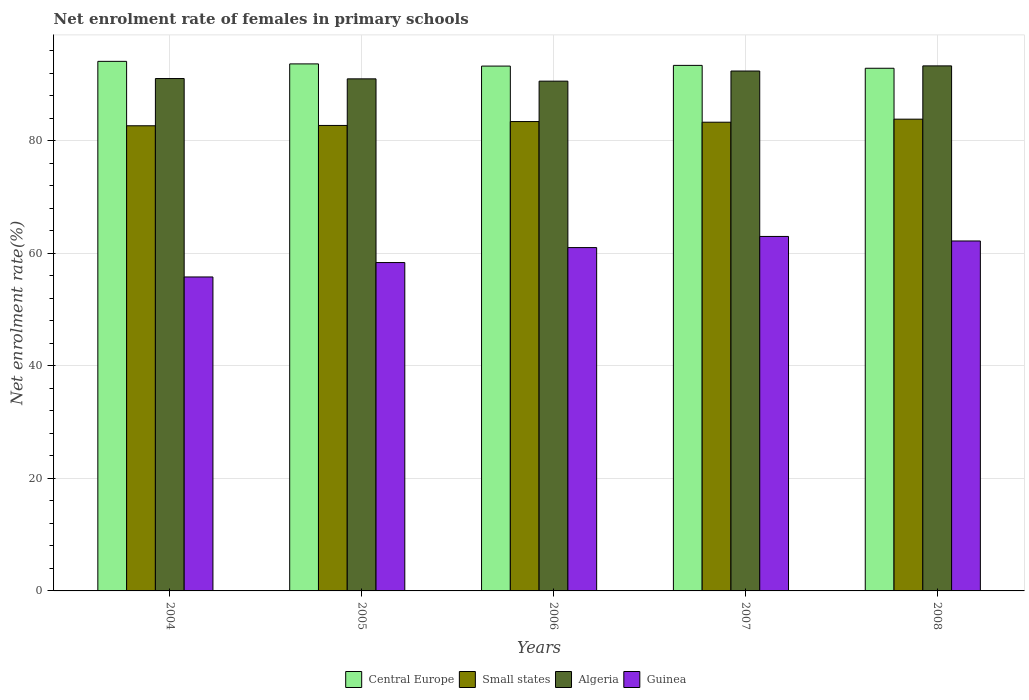How many groups of bars are there?
Your answer should be compact. 5. Are the number of bars per tick equal to the number of legend labels?
Offer a terse response. Yes. Are the number of bars on each tick of the X-axis equal?
Give a very brief answer. Yes. How many bars are there on the 4th tick from the left?
Give a very brief answer. 4. How many bars are there on the 3rd tick from the right?
Your response must be concise. 4. What is the label of the 4th group of bars from the left?
Your answer should be compact. 2007. What is the net enrolment rate of females in primary schools in Small states in 2005?
Make the answer very short. 82.73. Across all years, what is the maximum net enrolment rate of females in primary schools in Central Europe?
Make the answer very short. 94.12. Across all years, what is the minimum net enrolment rate of females in primary schools in Central Europe?
Your answer should be compact. 92.89. In which year was the net enrolment rate of females in primary schools in Algeria maximum?
Offer a very short reply. 2008. What is the total net enrolment rate of females in primary schools in Guinea in the graph?
Ensure brevity in your answer.  300.38. What is the difference between the net enrolment rate of females in primary schools in Central Europe in 2005 and that in 2006?
Your answer should be very brief. 0.39. What is the difference between the net enrolment rate of females in primary schools in Central Europe in 2008 and the net enrolment rate of females in primary schools in Small states in 2006?
Your answer should be compact. 9.47. What is the average net enrolment rate of females in primary schools in Algeria per year?
Your response must be concise. 91.68. In the year 2004, what is the difference between the net enrolment rate of females in primary schools in Algeria and net enrolment rate of females in primary schools in Guinea?
Offer a very short reply. 35.26. In how many years, is the net enrolment rate of females in primary schools in Algeria greater than 44 %?
Your answer should be very brief. 5. What is the ratio of the net enrolment rate of females in primary schools in Central Europe in 2004 to that in 2006?
Offer a terse response. 1.01. What is the difference between the highest and the second highest net enrolment rate of females in primary schools in Algeria?
Keep it short and to the point. 0.91. What is the difference between the highest and the lowest net enrolment rate of females in primary schools in Algeria?
Offer a terse response. 2.71. In how many years, is the net enrolment rate of females in primary schools in Guinea greater than the average net enrolment rate of females in primary schools in Guinea taken over all years?
Offer a terse response. 3. Is the sum of the net enrolment rate of females in primary schools in Central Europe in 2004 and 2006 greater than the maximum net enrolment rate of females in primary schools in Guinea across all years?
Make the answer very short. Yes. Is it the case that in every year, the sum of the net enrolment rate of females in primary schools in Guinea and net enrolment rate of females in primary schools in Central Europe is greater than the sum of net enrolment rate of females in primary schools in Algeria and net enrolment rate of females in primary schools in Small states?
Offer a very short reply. Yes. What does the 2nd bar from the left in 2006 represents?
Your response must be concise. Small states. What does the 4th bar from the right in 2008 represents?
Ensure brevity in your answer.  Central Europe. Is it the case that in every year, the sum of the net enrolment rate of females in primary schools in Small states and net enrolment rate of females in primary schools in Guinea is greater than the net enrolment rate of females in primary schools in Central Europe?
Your answer should be compact. Yes. How many years are there in the graph?
Ensure brevity in your answer.  5. What is the difference between two consecutive major ticks on the Y-axis?
Keep it short and to the point. 20. Are the values on the major ticks of Y-axis written in scientific E-notation?
Offer a terse response. No. Does the graph contain any zero values?
Provide a succinct answer. No. What is the title of the graph?
Offer a very short reply. Net enrolment rate of females in primary schools. What is the label or title of the X-axis?
Provide a succinct answer. Years. What is the label or title of the Y-axis?
Make the answer very short. Net enrolment rate(%). What is the Net enrolment rate(%) of Central Europe in 2004?
Give a very brief answer. 94.12. What is the Net enrolment rate(%) of Small states in 2004?
Ensure brevity in your answer.  82.67. What is the Net enrolment rate(%) in Algeria in 2004?
Offer a terse response. 91.06. What is the Net enrolment rate(%) in Guinea in 2004?
Ensure brevity in your answer.  55.8. What is the Net enrolment rate(%) of Central Europe in 2005?
Provide a short and direct response. 93.67. What is the Net enrolment rate(%) in Small states in 2005?
Make the answer very short. 82.73. What is the Net enrolment rate(%) of Algeria in 2005?
Your answer should be compact. 91.01. What is the Net enrolment rate(%) of Guinea in 2005?
Your answer should be compact. 58.36. What is the Net enrolment rate(%) of Central Europe in 2006?
Make the answer very short. 93.28. What is the Net enrolment rate(%) in Small states in 2006?
Your answer should be very brief. 83.42. What is the Net enrolment rate(%) of Algeria in 2006?
Keep it short and to the point. 90.6. What is the Net enrolment rate(%) in Guinea in 2006?
Provide a short and direct response. 61.02. What is the Net enrolment rate(%) in Central Europe in 2007?
Keep it short and to the point. 93.4. What is the Net enrolment rate(%) of Small states in 2007?
Provide a succinct answer. 83.3. What is the Net enrolment rate(%) of Algeria in 2007?
Make the answer very short. 92.4. What is the Net enrolment rate(%) of Guinea in 2007?
Make the answer very short. 63. What is the Net enrolment rate(%) in Central Europe in 2008?
Keep it short and to the point. 92.89. What is the Net enrolment rate(%) of Small states in 2008?
Offer a terse response. 83.85. What is the Net enrolment rate(%) in Algeria in 2008?
Provide a succinct answer. 93.31. What is the Net enrolment rate(%) of Guinea in 2008?
Ensure brevity in your answer.  62.2. Across all years, what is the maximum Net enrolment rate(%) in Central Europe?
Offer a very short reply. 94.12. Across all years, what is the maximum Net enrolment rate(%) in Small states?
Your answer should be very brief. 83.85. Across all years, what is the maximum Net enrolment rate(%) of Algeria?
Offer a terse response. 93.31. Across all years, what is the maximum Net enrolment rate(%) of Guinea?
Offer a terse response. 63. Across all years, what is the minimum Net enrolment rate(%) in Central Europe?
Offer a terse response. 92.89. Across all years, what is the minimum Net enrolment rate(%) of Small states?
Give a very brief answer. 82.67. Across all years, what is the minimum Net enrolment rate(%) of Algeria?
Keep it short and to the point. 90.6. Across all years, what is the minimum Net enrolment rate(%) of Guinea?
Your response must be concise. 55.8. What is the total Net enrolment rate(%) of Central Europe in the graph?
Your answer should be very brief. 467.36. What is the total Net enrolment rate(%) in Small states in the graph?
Your answer should be compact. 415.97. What is the total Net enrolment rate(%) in Algeria in the graph?
Offer a terse response. 458.39. What is the total Net enrolment rate(%) of Guinea in the graph?
Make the answer very short. 300.38. What is the difference between the Net enrolment rate(%) in Central Europe in 2004 and that in 2005?
Provide a succinct answer. 0.45. What is the difference between the Net enrolment rate(%) of Small states in 2004 and that in 2005?
Provide a short and direct response. -0.06. What is the difference between the Net enrolment rate(%) in Algeria in 2004 and that in 2005?
Give a very brief answer. 0.05. What is the difference between the Net enrolment rate(%) of Guinea in 2004 and that in 2005?
Provide a succinct answer. -2.56. What is the difference between the Net enrolment rate(%) in Central Europe in 2004 and that in 2006?
Ensure brevity in your answer.  0.84. What is the difference between the Net enrolment rate(%) of Small states in 2004 and that in 2006?
Your answer should be compact. -0.75. What is the difference between the Net enrolment rate(%) of Algeria in 2004 and that in 2006?
Offer a terse response. 0.46. What is the difference between the Net enrolment rate(%) in Guinea in 2004 and that in 2006?
Give a very brief answer. -5.22. What is the difference between the Net enrolment rate(%) of Central Europe in 2004 and that in 2007?
Give a very brief answer. 0.72. What is the difference between the Net enrolment rate(%) of Small states in 2004 and that in 2007?
Your response must be concise. -0.63. What is the difference between the Net enrolment rate(%) of Algeria in 2004 and that in 2007?
Make the answer very short. -1.34. What is the difference between the Net enrolment rate(%) in Guinea in 2004 and that in 2007?
Keep it short and to the point. -7.2. What is the difference between the Net enrolment rate(%) of Central Europe in 2004 and that in 2008?
Your answer should be compact. 1.23. What is the difference between the Net enrolment rate(%) in Small states in 2004 and that in 2008?
Offer a very short reply. -1.17. What is the difference between the Net enrolment rate(%) of Algeria in 2004 and that in 2008?
Ensure brevity in your answer.  -2.25. What is the difference between the Net enrolment rate(%) in Guinea in 2004 and that in 2008?
Your response must be concise. -6.4. What is the difference between the Net enrolment rate(%) of Central Europe in 2005 and that in 2006?
Make the answer very short. 0.39. What is the difference between the Net enrolment rate(%) in Small states in 2005 and that in 2006?
Your answer should be very brief. -0.69. What is the difference between the Net enrolment rate(%) of Algeria in 2005 and that in 2006?
Give a very brief answer. 0.41. What is the difference between the Net enrolment rate(%) in Guinea in 2005 and that in 2006?
Provide a short and direct response. -2.66. What is the difference between the Net enrolment rate(%) in Central Europe in 2005 and that in 2007?
Offer a terse response. 0.26. What is the difference between the Net enrolment rate(%) in Small states in 2005 and that in 2007?
Make the answer very short. -0.57. What is the difference between the Net enrolment rate(%) in Algeria in 2005 and that in 2007?
Make the answer very short. -1.39. What is the difference between the Net enrolment rate(%) of Guinea in 2005 and that in 2007?
Offer a very short reply. -4.64. What is the difference between the Net enrolment rate(%) in Central Europe in 2005 and that in 2008?
Offer a very short reply. 0.77. What is the difference between the Net enrolment rate(%) of Small states in 2005 and that in 2008?
Ensure brevity in your answer.  -1.12. What is the difference between the Net enrolment rate(%) of Algeria in 2005 and that in 2008?
Your response must be concise. -2.3. What is the difference between the Net enrolment rate(%) of Guinea in 2005 and that in 2008?
Your answer should be compact. -3.83. What is the difference between the Net enrolment rate(%) of Central Europe in 2006 and that in 2007?
Provide a succinct answer. -0.13. What is the difference between the Net enrolment rate(%) in Small states in 2006 and that in 2007?
Offer a very short reply. 0.12. What is the difference between the Net enrolment rate(%) of Algeria in 2006 and that in 2007?
Your answer should be compact. -1.8. What is the difference between the Net enrolment rate(%) of Guinea in 2006 and that in 2007?
Provide a succinct answer. -1.98. What is the difference between the Net enrolment rate(%) of Central Europe in 2006 and that in 2008?
Give a very brief answer. 0.38. What is the difference between the Net enrolment rate(%) in Small states in 2006 and that in 2008?
Offer a terse response. -0.42. What is the difference between the Net enrolment rate(%) of Algeria in 2006 and that in 2008?
Make the answer very short. -2.71. What is the difference between the Net enrolment rate(%) of Guinea in 2006 and that in 2008?
Offer a terse response. -1.17. What is the difference between the Net enrolment rate(%) of Central Europe in 2007 and that in 2008?
Provide a short and direct response. 0.51. What is the difference between the Net enrolment rate(%) of Small states in 2007 and that in 2008?
Provide a succinct answer. -0.54. What is the difference between the Net enrolment rate(%) of Algeria in 2007 and that in 2008?
Offer a very short reply. -0.91. What is the difference between the Net enrolment rate(%) of Guinea in 2007 and that in 2008?
Ensure brevity in your answer.  0.81. What is the difference between the Net enrolment rate(%) of Central Europe in 2004 and the Net enrolment rate(%) of Small states in 2005?
Your answer should be compact. 11.39. What is the difference between the Net enrolment rate(%) of Central Europe in 2004 and the Net enrolment rate(%) of Algeria in 2005?
Make the answer very short. 3.11. What is the difference between the Net enrolment rate(%) in Central Europe in 2004 and the Net enrolment rate(%) in Guinea in 2005?
Give a very brief answer. 35.76. What is the difference between the Net enrolment rate(%) of Small states in 2004 and the Net enrolment rate(%) of Algeria in 2005?
Offer a terse response. -8.34. What is the difference between the Net enrolment rate(%) of Small states in 2004 and the Net enrolment rate(%) of Guinea in 2005?
Your response must be concise. 24.31. What is the difference between the Net enrolment rate(%) of Algeria in 2004 and the Net enrolment rate(%) of Guinea in 2005?
Provide a short and direct response. 32.7. What is the difference between the Net enrolment rate(%) of Central Europe in 2004 and the Net enrolment rate(%) of Small states in 2006?
Your answer should be very brief. 10.7. What is the difference between the Net enrolment rate(%) in Central Europe in 2004 and the Net enrolment rate(%) in Algeria in 2006?
Provide a short and direct response. 3.52. What is the difference between the Net enrolment rate(%) in Central Europe in 2004 and the Net enrolment rate(%) in Guinea in 2006?
Give a very brief answer. 33.1. What is the difference between the Net enrolment rate(%) of Small states in 2004 and the Net enrolment rate(%) of Algeria in 2006?
Provide a short and direct response. -7.93. What is the difference between the Net enrolment rate(%) in Small states in 2004 and the Net enrolment rate(%) in Guinea in 2006?
Offer a terse response. 21.65. What is the difference between the Net enrolment rate(%) in Algeria in 2004 and the Net enrolment rate(%) in Guinea in 2006?
Ensure brevity in your answer.  30.04. What is the difference between the Net enrolment rate(%) in Central Europe in 2004 and the Net enrolment rate(%) in Small states in 2007?
Your answer should be very brief. 10.82. What is the difference between the Net enrolment rate(%) of Central Europe in 2004 and the Net enrolment rate(%) of Algeria in 2007?
Ensure brevity in your answer.  1.72. What is the difference between the Net enrolment rate(%) of Central Europe in 2004 and the Net enrolment rate(%) of Guinea in 2007?
Ensure brevity in your answer.  31.12. What is the difference between the Net enrolment rate(%) in Small states in 2004 and the Net enrolment rate(%) in Algeria in 2007?
Keep it short and to the point. -9.73. What is the difference between the Net enrolment rate(%) in Small states in 2004 and the Net enrolment rate(%) in Guinea in 2007?
Offer a very short reply. 19.67. What is the difference between the Net enrolment rate(%) of Algeria in 2004 and the Net enrolment rate(%) of Guinea in 2007?
Your answer should be compact. 28.06. What is the difference between the Net enrolment rate(%) of Central Europe in 2004 and the Net enrolment rate(%) of Small states in 2008?
Ensure brevity in your answer.  10.27. What is the difference between the Net enrolment rate(%) in Central Europe in 2004 and the Net enrolment rate(%) in Algeria in 2008?
Provide a short and direct response. 0.81. What is the difference between the Net enrolment rate(%) of Central Europe in 2004 and the Net enrolment rate(%) of Guinea in 2008?
Ensure brevity in your answer.  31.92. What is the difference between the Net enrolment rate(%) of Small states in 2004 and the Net enrolment rate(%) of Algeria in 2008?
Make the answer very short. -10.64. What is the difference between the Net enrolment rate(%) in Small states in 2004 and the Net enrolment rate(%) in Guinea in 2008?
Provide a succinct answer. 20.48. What is the difference between the Net enrolment rate(%) of Algeria in 2004 and the Net enrolment rate(%) of Guinea in 2008?
Offer a terse response. 28.87. What is the difference between the Net enrolment rate(%) in Central Europe in 2005 and the Net enrolment rate(%) in Small states in 2006?
Keep it short and to the point. 10.25. What is the difference between the Net enrolment rate(%) in Central Europe in 2005 and the Net enrolment rate(%) in Algeria in 2006?
Your response must be concise. 3.07. What is the difference between the Net enrolment rate(%) of Central Europe in 2005 and the Net enrolment rate(%) of Guinea in 2006?
Your answer should be very brief. 32.65. What is the difference between the Net enrolment rate(%) of Small states in 2005 and the Net enrolment rate(%) of Algeria in 2006?
Provide a short and direct response. -7.87. What is the difference between the Net enrolment rate(%) in Small states in 2005 and the Net enrolment rate(%) in Guinea in 2006?
Provide a succinct answer. 21.71. What is the difference between the Net enrolment rate(%) in Algeria in 2005 and the Net enrolment rate(%) in Guinea in 2006?
Make the answer very short. 29.99. What is the difference between the Net enrolment rate(%) of Central Europe in 2005 and the Net enrolment rate(%) of Small states in 2007?
Offer a terse response. 10.37. What is the difference between the Net enrolment rate(%) of Central Europe in 2005 and the Net enrolment rate(%) of Algeria in 2007?
Offer a terse response. 1.27. What is the difference between the Net enrolment rate(%) in Central Europe in 2005 and the Net enrolment rate(%) in Guinea in 2007?
Ensure brevity in your answer.  30.67. What is the difference between the Net enrolment rate(%) in Small states in 2005 and the Net enrolment rate(%) in Algeria in 2007?
Your answer should be very brief. -9.67. What is the difference between the Net enrolment rate(%) in Small states in 2005 and the Net enrolment rate(%) in Guinea in 2007?
Give a very brief answer. 19.73. What is the difference between the Net enrolment rate(%) in Algeria in 2005 and the Net enrolment rate(%) in Guinea in 2007?
Provide a succinct answer. 28.01. What is the difference between the Net enrolment rate(%) in Central Europe in 2005 and the Net enrolment rate(%) in Small states in 2008?
Keep it short and to the point. 9.82. What is the difference between the Net enrolment rate(%) of Central Europe in 2005 and the Net enrolment rate(%) of Algeria in 2008?
Provide a short and direct response. 0.35. What is the difference between the Net enrolment rate(%) in Central Europe in 2005 and the Net enrolment rate(%) in Guinea in 2008?
Ensure brevity in your answer.  31.47. What is the difference between the Net enrolment rate(%) of Small states in 2005 and the Net enrolment rate(%) of Algeria in 2008?
Make the answer very short. -10.58. What is the difference between the Net enrolment rate(%) in Small states in 2005 and the Net enrolment rate(%) in Guinea in 2008?
Make the answer very short. 20.53. What is the difference between the Net enrolment rate(%) in Algeria in 2005 and the Net enrolment rate(%) in Guinea in 2008?
Your answer should be very brief. 28.81. What is the difference between the Net enrolment rate(%) of Central Europe in 2006 and the Net enrolment rate(%) of Small states in 2007?
Make the answer very short. 9.98. What is the difference between the Net enrolment rate(%) of Central Europe in 2006 and the Net enrolment rate(%) of Algeria in 2007?
Your answer should be compact. 0.88. What is the difference between the Net enrolment rate(%) in Central Europe in 2006 and the Net enrolment rate(%) in Guinea in 2007?
Your response must be concise. 30.28. What is the difference between the Net enrolment rate(%) of Small states in 2006 and the Net enrolment rate(%) of Algeria in 2007?
Offer a very short reply. -8.98. What is the difference between the Net enrolment rate(%) of Small states in 2006 and the Net enrolment rate(%) of Guinea in 2007?
Offer a very short reply. 20.42. What is the difference between the Net enrolment rate(%) of Algeria in 2006 and the Net enrolment rate(%) of Guinea in 2007?
Your answer should be very brief. 27.6. What is the difference between the Net enrolment rate(%) in Central Europe in 2006 and the Net enrolment rate(%) in Small states in 2008?
Your answer should be compact. 9.43. What is the difference between the Net enrolment rate(%) in Central Europe in 2006 and the Net enrolment rate(%) in Algeria in 2008?
Offer a terse response. -0.04. What is the difference between the Net enrolment rate(%) of Central Europe in 2006 and the Net enrolment rate(%) of Guinea in 2008?
Your response must be concise. 31.08. What is the difference between the Net enrolment rate(%) in Small states in 2006 and the Net enrolment rate(%) in Algeria in 2008?
Your response must be concise. -9.89. What is the difference between the Net enrolment rate(%) in Small states in 2006 and the Net enrolment rate(%) in Guinea in 2008?
Give a very brief answer. 21.23. What is the difference between the Net enrolment rate(%) in Algeria in 2006 and the Net enrolment rate(%) in Guinea in 2008?
Your answer should be compact. 28.41. What is the difference between the Net enrolment rate(%) of Central Europe in 2007 and the Net enrolment rate(%) of Small states in 2008?
Your response must be concise. 9.56. What is the difference between the Net enrolment rate(%) of Central Europe in 2007 and the Net enrolment rate(%) of Algeria in 2008?
Your response must be concise. 0.09. What is the difference between the Net enrolment rate(%) in Central Europe in 2007 and the Net enrolment rate(%) in Guinea in 2008?
Provide a short and direct response. 31.21. What is the difference between the Net enrolment rate(%) in Small states in 2007 and the Net enrolment rate(%) in Algeria in 2008?
Provide a succinct answer. -10.01. What is the difference between the Net enrolment rate(%) in Small states in 2007 and the Net enrolment rate(%) in Guinea in 2008?
Ensure brevity in your answer.  21.11. What is the difference between the Net enrolment rate(%) of Algeria in 2007 and the Net enrolment rate(%) of Guinea in 2008?
Offer a terse response. 30.21. What is the average Net enrolment rate(%) in Central Europe per year?
Offer a terse response. 93.47. What is the average Net enrolment rate(%) of Small states per year?
Provide a short and direct response. 83.19. What is the average Net enrolment rate(%) of Algeria per year?
Provide a short and direct response. 91.68. What is the average Net enrolment rate(%) of Guinea per year?
Your answer should be compact. 60.08. In the year 2004, what is the difference between the Net enrolment rate(%) in Central Europe and Net enrolment rate(%) in Small states?
Your answer should be compact. 11.45. In the year 2004, what is the difference between the Net enrolment rate(%) of Central Europe and Net enrolment rate(%) of Algeria?
Ensure brevity in your answer.  3.06. In the year 2004, what is the difference between the Net enrolment rate(%) in Central Europe and Net enrolment rate(%) in Guinea?
Provide a short and direct response. 38.32. In the year 2004, what is the difference between the Net enrolment rate(%) in Small states and Net enrolment rate(%) in Algeria?
Your answer should be very brief. -8.39. In the year 2004, what is the difference between the Net enrolment rate(%) of Small states and Net enrolment rate(%) of Guinea?
Your response must be concise. 26.87. In the year 2004, what is the difference between the Net enrolment rate(%) of Algeria and Net enrolment rate(%) of Guinea?
Your answer should be compact. 35.26. In the year 2005, what is the difference between the Net enrolment rate(%) of Central Europe and Net enrolment rate(%) of Small states?
Your answer should be compact. 10.94. In the year 2005, what is the difference between the Net enrolment rate(%) in Central Europe and Net enrolment rate(%) in Algeria?
Offer a terse response. 2.66. In the year 2005, what is the difference between the Net enrolment rate(%) of Central Europe and Net enrolment rate(%) of Guinea?
Provide a succinct answer. 35.31. In the year 2005, what is the difference between the Net enrolment rate(%) of Small states and Net enrolment rate(%) of Algeria?
Your answer should be compact. -8.28. In the year 2005, what is the difference between the Net enrolment rate(%) in Small states and Net enrolment rate(%) in Guinea?
Offer a very short reply. 24.37. In the year 2005, what is the difference between the Net enrolment rate(%) in Algeria and Net enrolment rate(%) in Guinea?
Make the answer very short. 32.65. In the year 2006, what is the difference between the Net enrolment rate(%) in Central Europe and Net enrolment rate(%) in Small states?
Give a very brief answer. 9.86. In the year 2006, what is the difference between the Net enrolment rate(%) of Central Europe and Net enrolment rate(%) of Algeria?
Give a very brief answer. 2.68. In the year 2006, what is the difference between the Net enrolment rate(%) of Central Europe and Net enrolment rate(%) of Guinea?
Provide a succinct answer. 32.26. In the year 2006, what is the difference between the Net enrolment rate(%) of Small states and Net enrolment rate(%) of Algeria?
Give a very brief answer. -7.18. In the year 2006, what is the difference between the Net enrolment rate(%) of Small states and Net enrolment rate(%) of Guinea?
Your answer should be compact. 22.4. In the year 2006, what is the difference between the Net enrolment rate(%) of Algeria and Net enrolment rate(%) of Guinea?
Your response must be concise. 29.58. In the year 2007, what is the difference between the Net enrolment rate(%) in Central Europe and Net enrolment rate(%) in Small states?
Provide a succinct answer. 10.1. In the year 2007, what is the difference between the Net enrolment rate(%) in Central Europe and Net enrolment rate(%) in Guinea?
Keep it short and to the point. 30.4. In the year 2007, what is the difference between the Net enrolment rate(%) of Small states and Net enrolment rate(%) of Algeria?
Provide a short and direct response. -9.1. In the year 2007, what is the difference between the Net enrolment rate(%) in Small states and Net enrolment rate(%) in Guinea?
Ensure brevity in your answer.  20.3. In the year 2007, what is the difference between the Net enrolment rate(%) of Algeria and Net enrolment rate(%) of Guinea?
Your response must be concise. 29.4. In the year 2008, what is the difference between the Net enrolment rate(%) of Central Europe and Net enrolment rate(%) of Small states?
Your response must be concise. 9.05. In the year 2008, what is the difference between the Net enrolment rate(%) in Central Europe and Net enrolment rate(%) in Algeria?
Ensure brevity in your answer.  -0.42. In the year 2008, what is the difference between the Net enrolment rate(%) of Central Europe and Net enrolment rate(%) of Guinea?
Your answer should be very brief. 30.7. In the year 2008, what is the difference between the Net enrolment rate(%) of Small states and Net enrolment rate(%) of Algeria?
Keep it short and to the point. -9.47. In the year 2008, what is the difference between the Net enrolment rate(%) of Small states and Net enrolment rate(%) of Guinea?
Offer a very short reply. 21.65. In the year 2008, what is the difference between the Net enrolment rate(%) in Algeria and Net enrolment rate(%) in Guinea?
Your answer should be compact. 31.12. What is the ratio of the Net enrolment rate(%) in Small states in 2004 to that in 2005?
Make the answer very short. 1. What is the ratio of the Net enrolment rate(%) in Guinea in 2004 to that in 2005?
Give a very brief answer. 0.96. What is the ratio of the Net enrolment rate(%) in Small states in 2004 to that in 2006?
Ensure brevity in your answer.  0.99. What is the ratio of the Net enrolment rate(%) of Algeria in 2004 to that in 2006?
Your response must be concise. 1.01. What is the ratio of the Net enrolment rate(%) of Guinea in 2004 to that in 2006?
Your answer should be very brief. 0.91. What is the ratio of the Net enrolment rate(%) in Central Europe in 2004 to that in 2007?
Provide a short and direct response. 1.01. What is the ratio of the Net enrolment rate(%) of Small states in 2004 to that in 2007?
Your answer should be compact. 0.99. What is the ratio of the Net enrolment rate(%) of Algeria in 2004 to that in 2007?
Offer a terse response. 0.99. What is the ratio of the Net enrolment rate(%) of Guinea in 2004 to that in 2007?
Keep it short and to the point. 0.89. What is the ratio of the Net enrolment rate(%) in Central Europe in 2004 to that in 2008?
Give a very brief answer. 1.01. What is the ratio of the Net enrolment rate(%) in Small states in 2004 to that in 2008?
Your answer should be compact. 0.99. What is the ratio of the Net enrolment rate(%) of Algeria in 2004 to that in 2008?
Provide a short and direct response. 0.98. What is the ratio of the Net enrolment rate(%) in Guinea in 2004 to that in 2008?
Your answer should be compact. 0.9. What is the ratio of the Net enrolment rate(%) of Algeria in 2005 to that in 2006?
Offer a very short reply. 1. What is the ratio of the Net enrolment rate(%) of Guinea in 2005 to that in 2006?
Your answer should be very brief. 0.96. What is the ratio of the Net enrolment rate(%) in Algeria in 2005 to that in 2007?
Your answer should be compact. 0.98. What is the ratio of the Net enrolment rate(%) in Guinea in 2005 to that in 2007?
Provide a succinct answer. 0.93. What is the ratio of the Net enrolment rate(%) of Central Europe in 2005 to that in 2008?
Your answer should be very brief. 1.01. What is the ratio of the Net enrolment rate(%) in Small states in 2005 to that in 2008?
Your response must be concise. 0.99. What is the ratio of the Net enrolment rate(%) in Algeria in 2005 to that in 2008?
Ensure brevity in your answer.  0.98. What is the ratio of the Net enrolment rate(%) of Guinea in 2005 to that in 2008?
Your answer should be compact. 0.94. What is the ratio of the Net enrolment rate(%) in Algeria in 2006 to that in 2007?
Ensure brevity in your answer.  0.98. What is the ratio of the Net enrolment rate(%) in Guinea in 2006 to that in 2007?
Ensure brevity in your answer.  0.97. What is the ratio of the Net enrolment rate(%) of Central Europe in 2006 to that in 2008?
Provide a succinct answer. 1. What is the ratio of the Net enrolment rate(%) of Algeria in 2006 to that in 2008?
Offer a terse response. 0.97. What is the ratio of the Net enrolment rate(%) in Guinea in 2006 to that in 2008?
Give a very brief answer. 0.98. What is the ratio of the Net enrolment rate(%) of Central Europe in 2007 to that in 2008?
Make the answer very short. 1.01. What is the ratio of the Net enrolment rate(%) of Algeria in 2007 to that in 2008?
Make the answer very short. 0.99. What is the ratio of the Net enrolment rate(%) of Guinea in 2007 to that in 2008?
Provide a succinct answer. 1.01. What is the difference between the highest and the second highest Net enrolment rate(%) of Central Europe?
Provide a succinct answer. 0.45. What is the difference between the highest and the second highest Net enrolment rate(%) of Small states?
Provide a short and direct response. 0.42. What is the difference between the highest and the second highest Net enrolment rate(%) of Algeria?
Your answer should be very brief. 0.91. What is the difference between the highest and the second highest Net enrolment rate(%) of Guinea?
Offer a terse response. 0.81. What is the difference between the highest and the lowest Net enrolment rate(%) of Central Europe?
Give a very brief answer. 1.23. What is the difference between the highest and the lowest Net enrolment rate(%) of Small states?
Provide a succinct answer. 1.17. What is the difference between the highest and the lowest Net enrolment rate(%) in Algeria?
Offer a terse response. 2.71. What is the difference between the highest and the lowest Net enrolment rate(%) of Guinea?
Your answer should be very brief. 7.2. 